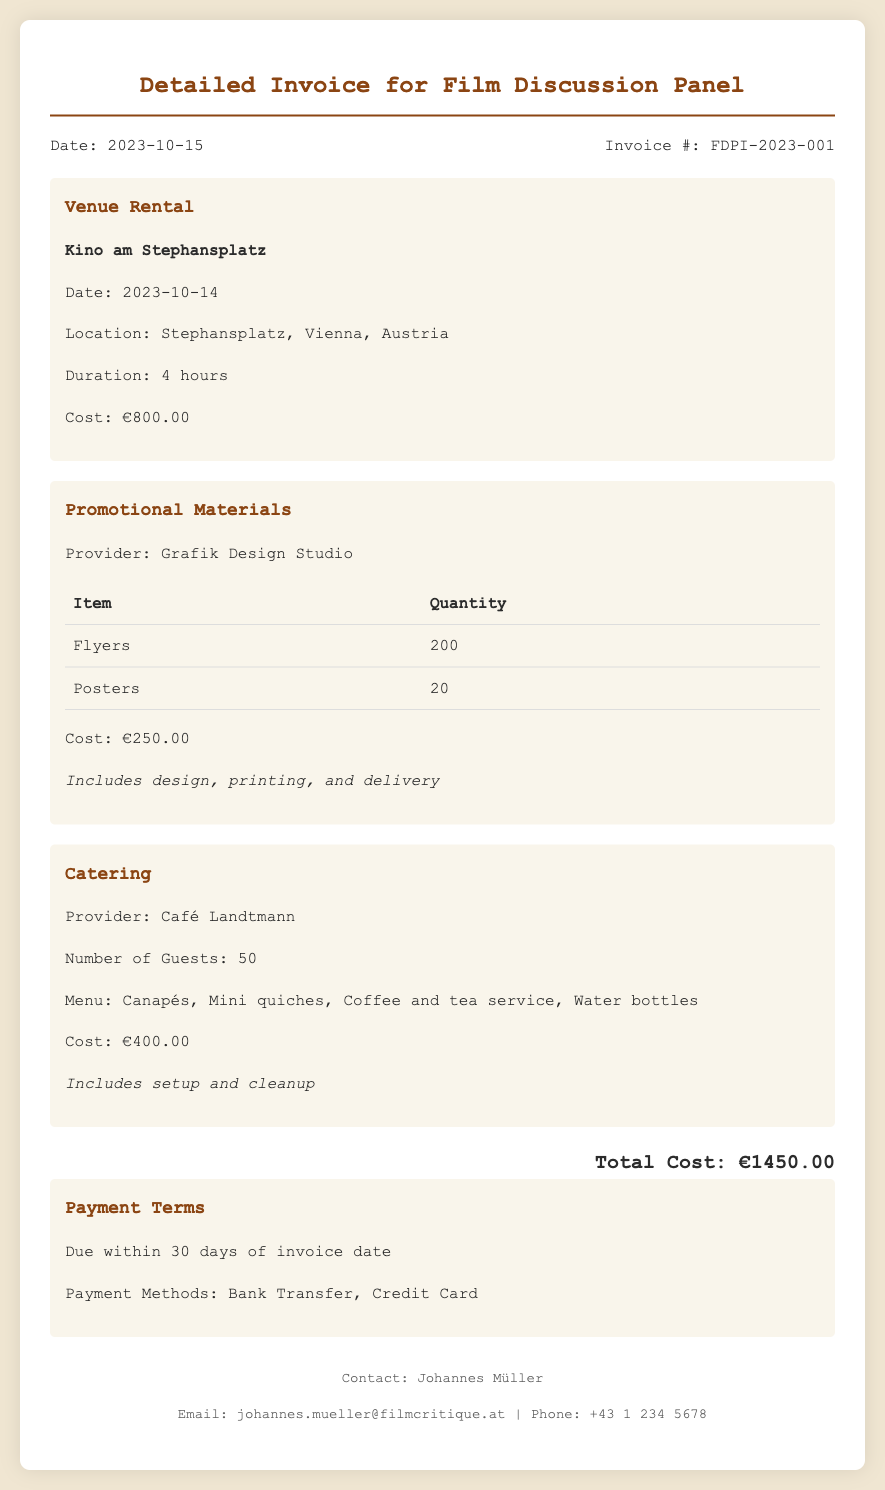What is the date of the invoice? The date of the invoice is clearly stated in the document's header section.
Answer: 2023-10-15 What is the venue rental cost? The document specifies the cost for venue rental under the section for Venue Rental.
Answer: €800.00 Who provided the promotional materials? The provider of the promotional materials is explicitly mentioned in the section on Promotional Materials.
Answer: Grafik Design Studio How many guests were catered for? The number of guests is noted in the Catering section, providing a specific figure.
Answer: 50 What is the total cost of the invoice? The total cost is presented at the bottom of the document in a highlighted section.
Answer: €1450.00 What type of menu was provided for catering? The type of menu is detailed in the Catering section, outlining the items offered.
Answer: Canapés, Mini quiches, Coffee and tea service, Water bottles What are the payment methods listed? The payment methods can be found in the Payment Terms section of the document.
Answer: Bank Transfer, Credit Card When is the payment due? The due date for payment is specified under the Payment Terms section.
Answer: Within 30 days of invoice date 